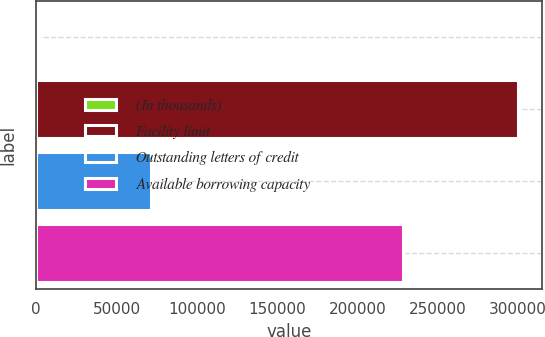Convert chart. <chart><loc_0><loc_0><loc_500><loc_500><bar_chart><fcel>(In thousands)<fcel>Facility limit<fcel>Outstanding letters of credit<fcel>Available borrowing capacity<nl><fcel>2017<fcel>300000<fcel>71368<fcel>228632<nl></chart> 